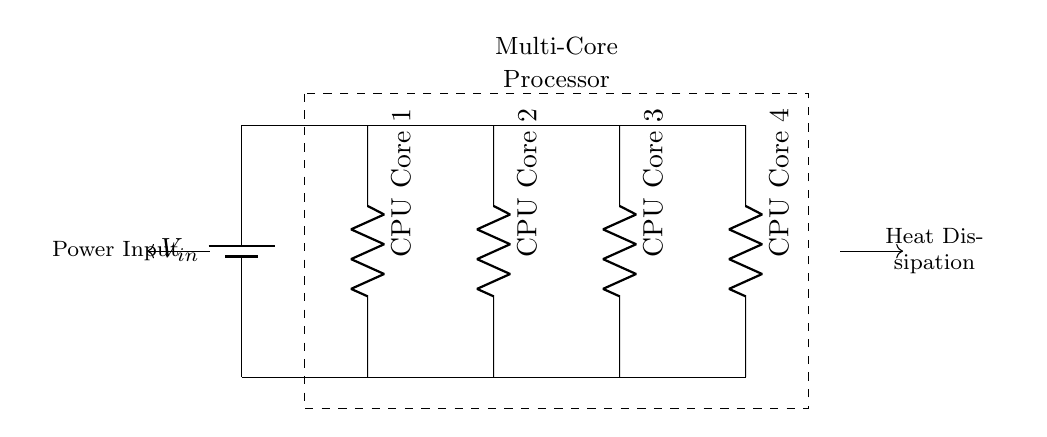What is the total number of CPU cores depicted in the circuit? The circuit diagram shows four distinct components labeled as CPU Core 1, CPU Core 2, CPU Core 3, and CPU Core 4. Each of these components represents a core, leading to the conclusion that the total number is four.
Answer: Four What type of circuit is depicted in the diagram? The components are connected in parallel, which can be deduced from the arrangement where each CPU core has its own branch directly connected to the power supply, allowing them to operate independently.
Answer: Parallel What is the role of the battery in this circuit? The battery is the source of voltage input, as indicated by the label V_in. It provides the necessary electrical energy to the multi-core processor configuration for its operation and cooling requirements.
Answer: Voltage source Which direction does the heat dissipation flow according to the diagram? The arrow indicating heat dissipation points towards the right, suggesting that the heat generated by the CPU cores must be expelled from the system, which is essential for maintaining optimal functioning temperatures.
Answer: Right If each CPU core has a resistance of 5 ohms, how would the total resistance be calculated? In a parallel circuit, the total resistance (R_total) is calculated using the formula 1/R_total = 1/R1 + 1/R2 + 1/R3 + 1/R4. With each resistor at 5 ohms, you calculate it as follows: 1/R_total = 1/5 + 1/5 + 1/5 + 1/5 = 4/5, leading to R_total = 5/4, which equals 1.25 ohms.
Answer: 1.25 ohms 